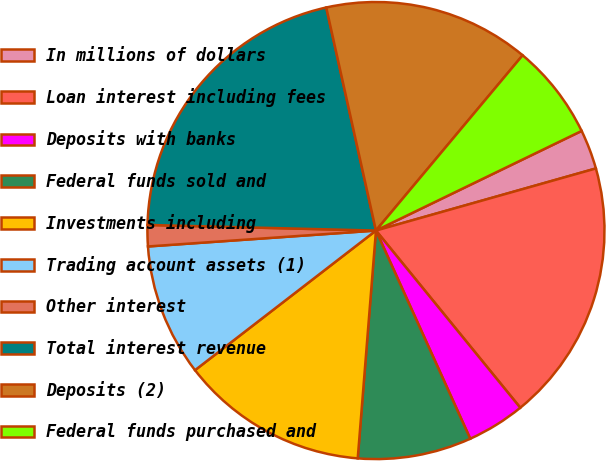Convert chart to OTSL. <chart><loc_0><loc_0><loc_500><loc_500><pie_chart><fcel>In millions of dollars<fcel>Loan interest including fees<fcel>Deposits with banks<fcel>Federal funds sold and<fcel>Investments including<fcel>Trading account assets (1)<fcel>Other interest<fcel>Total interest revenue<fcel>Deposits (2)<fcel>Federal funds purchased and<nl><fcel>2.8%<fcel>18.5%<fcel>4.11%<fcel>8.04%<fcel>13.27%<fcel>9.35%<fcel>1.5%<fcel>21.12%<fcel>14.58%<fcel>6.73%<nl></chart> 